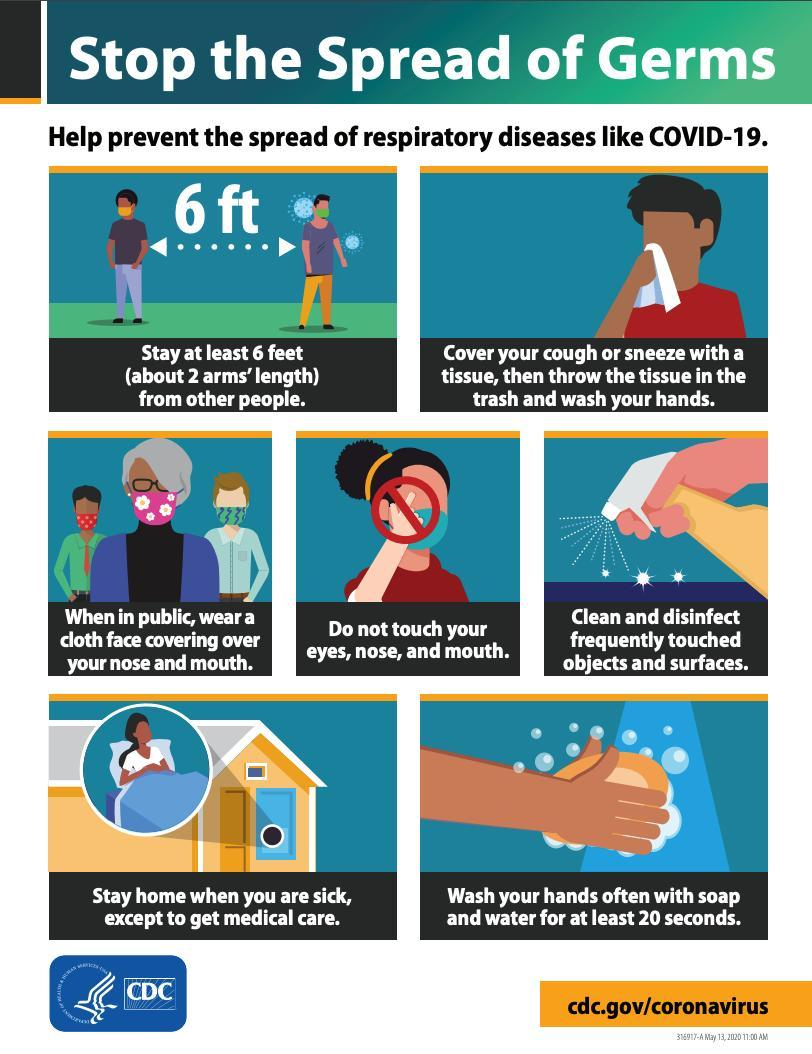How many don't are mentioned  in this infographic image?
Answer the question with a short phrase. 1 How many people are wearing a mask in this infographic image? 6 How long one should wash their hands in order to prevent the spread of COVID-19? 20 seconds 